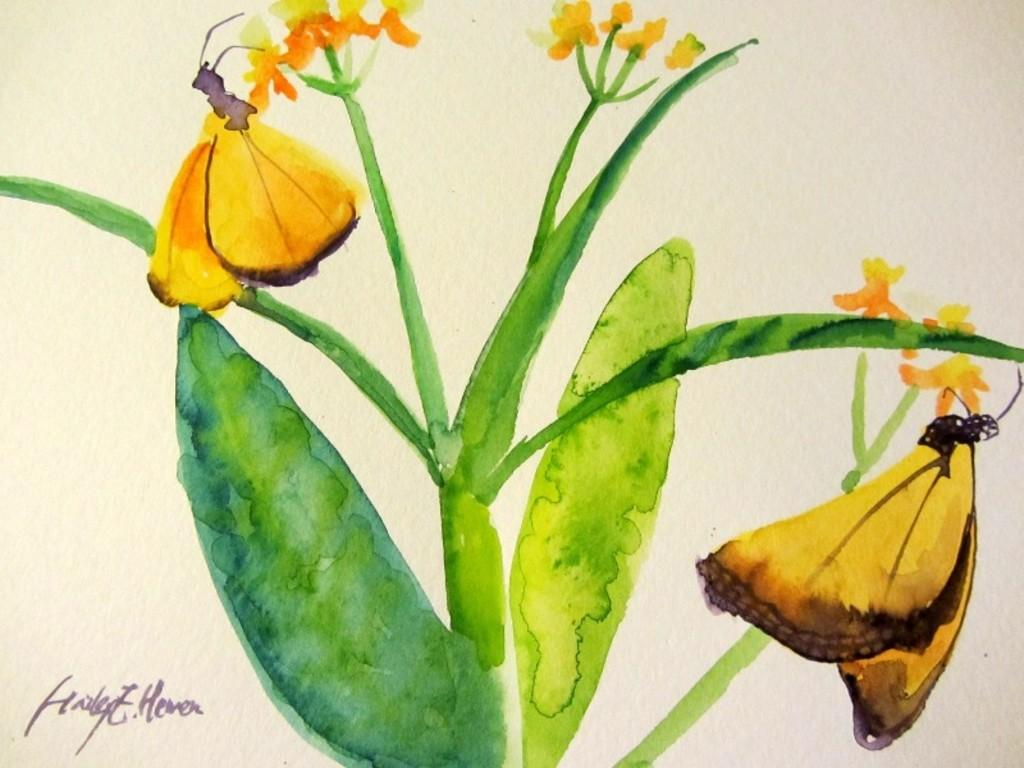What type of art piece is in the image? The image contains an art piece featuring butterflies and flowers. What other elements are included in the art piece? There is text present in the art piece. Can you describe the subject matter of the art piece? The art piece features butterflies and flowers. How many kites are depicted in the art piece? There are no kites present in the art piece; it features butterflies and flowers. What does the text in the art piece say about believing in oneself? The text in the art piece does not mention anything about believing in oneself, as the provided facts do not mention any specific message or theme. 